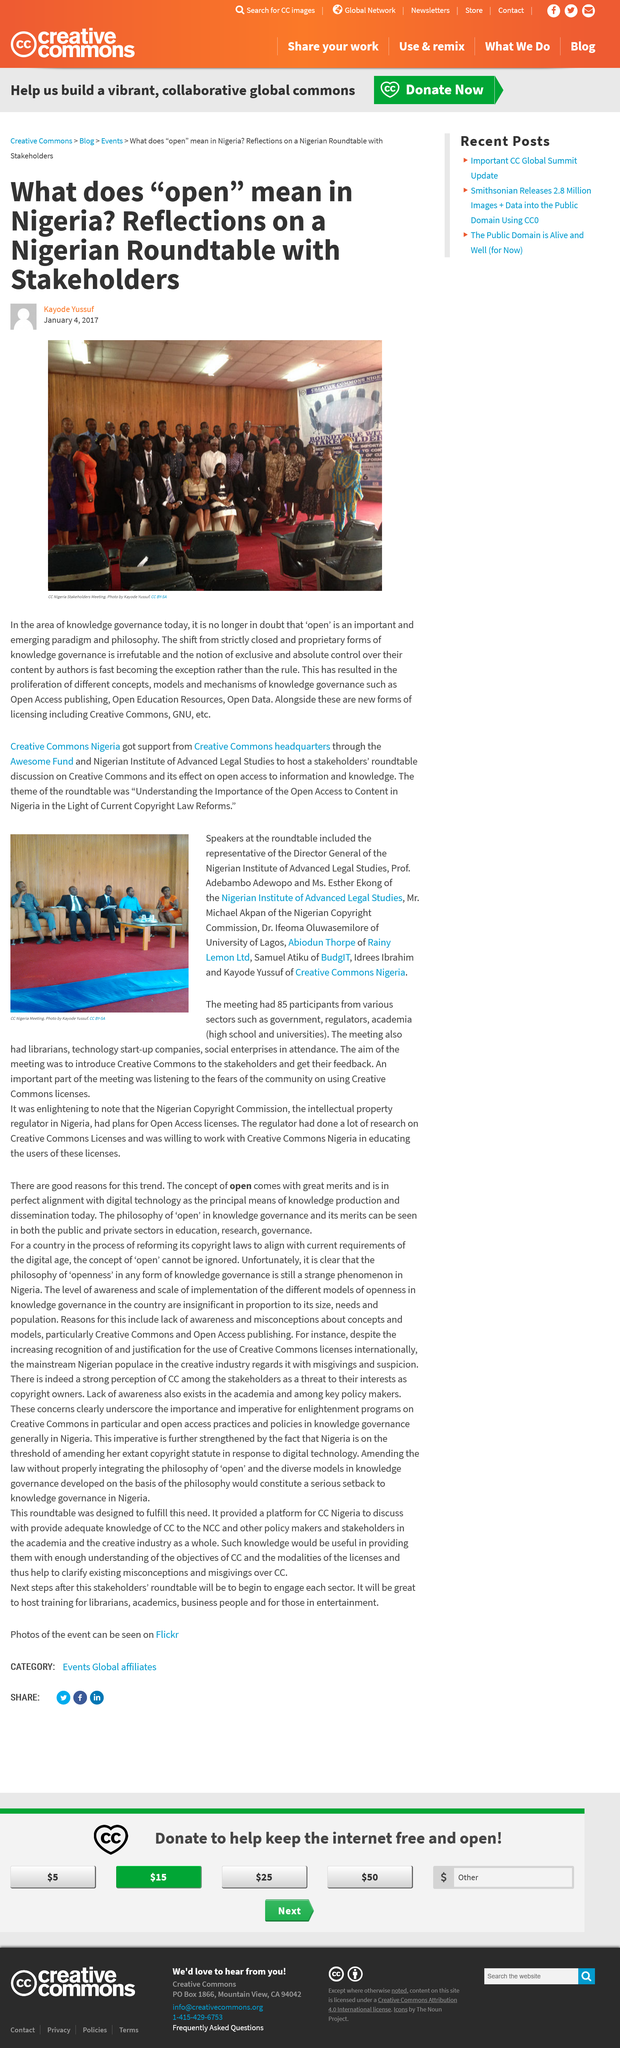Highlight a few significant elements in this photo. The article was written by Kayode Yussuf. The CC Nigeria meeting had 85 participants. Kayode Yussuf took the photo of the CC Nigeria Stakeholders meeting. The article image is from a meeting in Nigeria. The participants at the CC Nigeria Meeting included representatives from the government, regulators, academia, and social enterprises, from various sectors. 